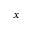Convert formula to latex. <formula><loc_0><loc_0><loc_500><loc_500>x</formula> 